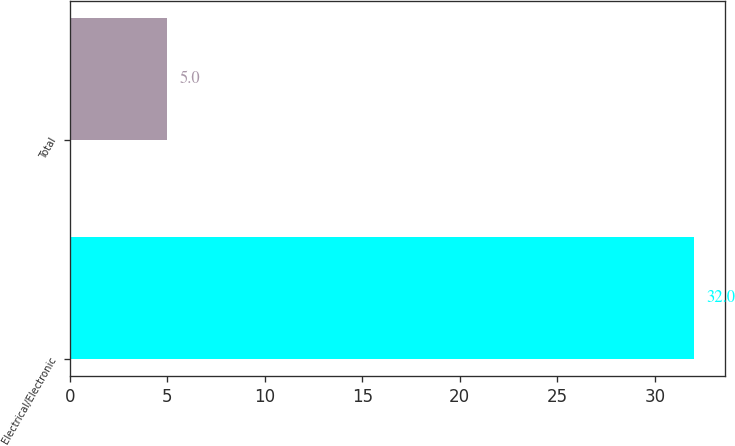Convert chart. <chart><loc_0><loc_0><loc_500><loc_500><bar_chart><fcel>Electrical/Electronic<fcel>Total<nl><fcel>32<fcel>5<nl></chart> 